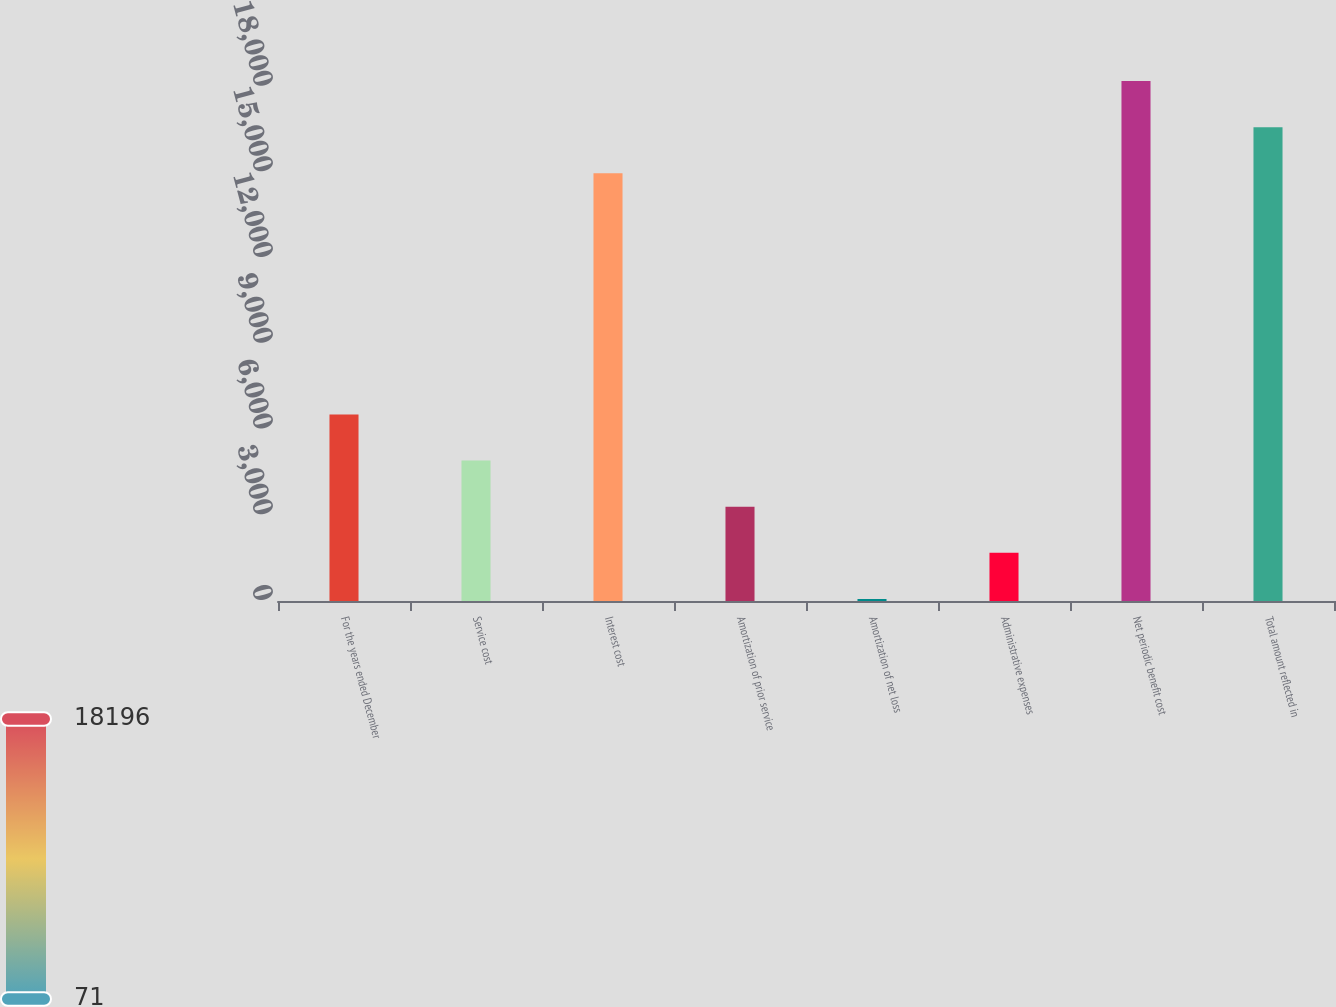<chart> <loc_0><loc_0><loc_500><loc_500><bar_chart><fcel>For the years ended December<fcel>Service cost<fcel>Interest cost<fcel>Amortization of prior service<fcel>Amortization of net loss<fcel>Administrative expenses<fcel>Net periodic benefit cost<fcel>Total amount reflected in<nl><fcel>6529.8<fcel>4915.1<fcel>14967<fcel>3300.4<fcel>71<fcel>1685.7<fcel>18196.4<fcel>16581.7<nl></chart> 